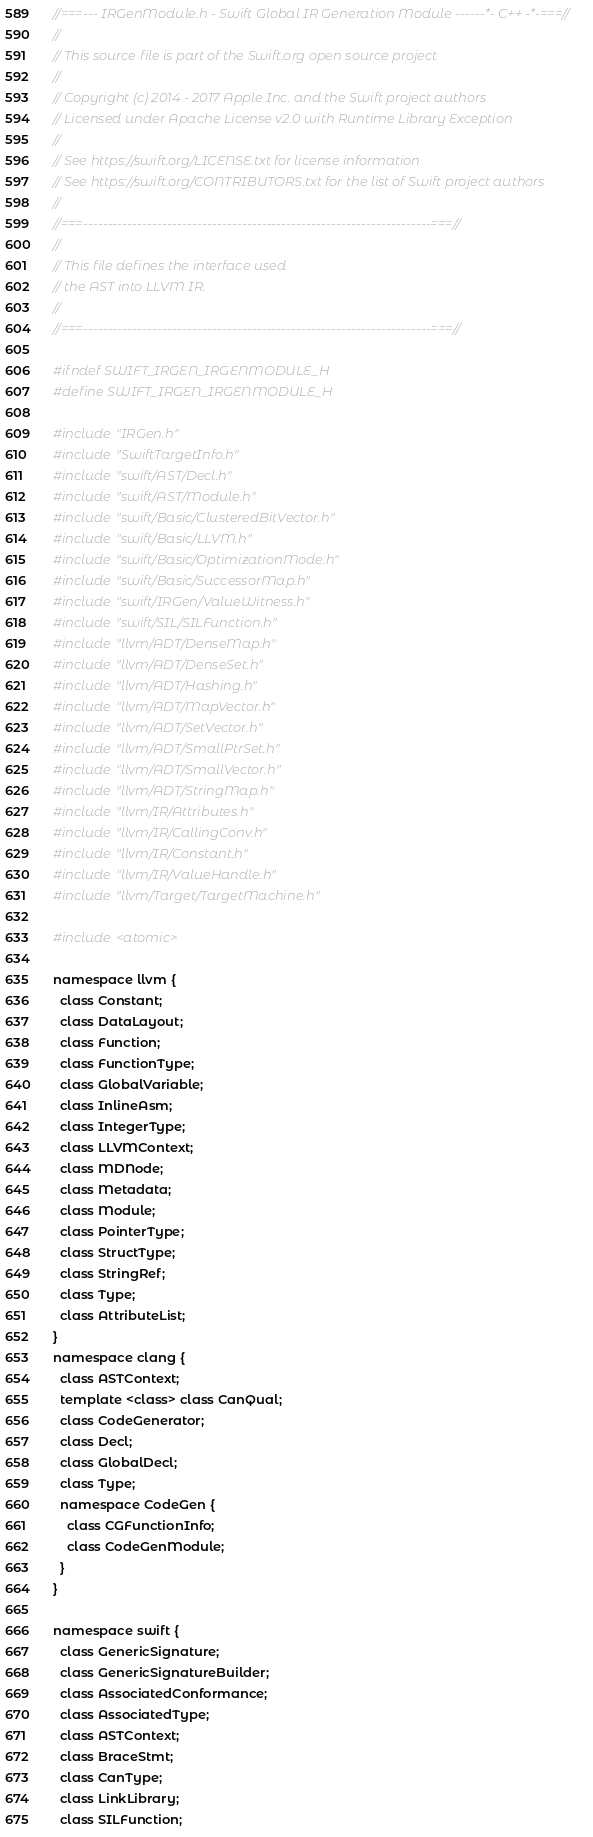<code> <loc_0><loc_0><loc_500><loc_500><_C_>//===--- IRGenModule.h - Swift Global IR Generation Module ------*- C++ -*-===//
//
// This source file is part of the Swift.org open source project
//
// Copyright (c) 2014 - 2017 Apple Inc. and the Swift project authors
// Licensed under Apache License v2.0 with Runtime Library Exception
//
// See https://swift.org/LICENSE.txt for license information
// See https://swift.org/CONTRIBUTORS.txt for the list of Swift project authors
//
//===----------------------------------------------------------------------===//
//
// This file defines the interface used 
// the AST into LLVM IR.
//
//===----------------------------------------------------------------------===//

#ifndef SWIFT_IRGEN_IRGENMODULE_H
#define SWIFT_IRGEN_IRGENMODULE_H

#include "IRGen.h"
#include "SwiftTargetInfo.h"
#include "swift/AST/Decl.h"
#include "swift/AST/Module.h"
#include "swift/Basic/ClusteredBitVector.h"
#include "swift/Basic/LLVM.h"
#include "swift/Basic/OptimizationMode.h"
#include "swift/Basic/SuccessorMap.h"
#include "swift/IRGen/ValueWitness.h"
#include "swift/SIL/SILFunction.h"
#include "llvm/ADT/DenseMap.h"
#include "llvm/ADT/DenseSet.h"
#include "llvm/ADT/Hashing.h"
#include "llvm/ADT/MapVector.h"
#include "llvm/ADT/SetVector.h"
#include "llvm/ADT/SmallPtrSet.h"
#include "llvm/ADT/SmallVector.h"
#include "llvm/ADT/StringMap.h"
#include "llvm/IR/Attributes.h"
#include "llvm/IR/CallingConv.h"
#include "llvm/IR/Constant.h"
#include "llvm/IR/ValueHandle.h"
#include "llvm/Target/TargetMachine.h"

#include <atomic>

namespace llvm {
  class Constant;
  class DataLayout;
  class Function;
  class FunctionType;
  class GlobalVariable;
  class InlineAsm;
  class IntegerType;
  class LLVMContext;
  class MDNode;
  class Metadata;
  class Module;
  class PointerType;
  class StructType;
  class StringRef;
  class Type;
  class AttributeList;
}
namespace clang {
  class ASTContext;
  template <class> class CanQual;
  class CodeGenerator;
  class Decl;
  class GlobalDecl;
  class Type;
  namespace CodeGen {
    class CGFunctionInfo;
    class CodeGenModule;
  }
}

namespace swift {
  class GenericSignature;
  class GenericSignatureBuilder;
  class AssociatedConformance;
  class AssociatedType;
  class ASTContext;
  class BraceStmt;
  class CanType;
  class LinkLibrary;
  class SILFunction;</code> 